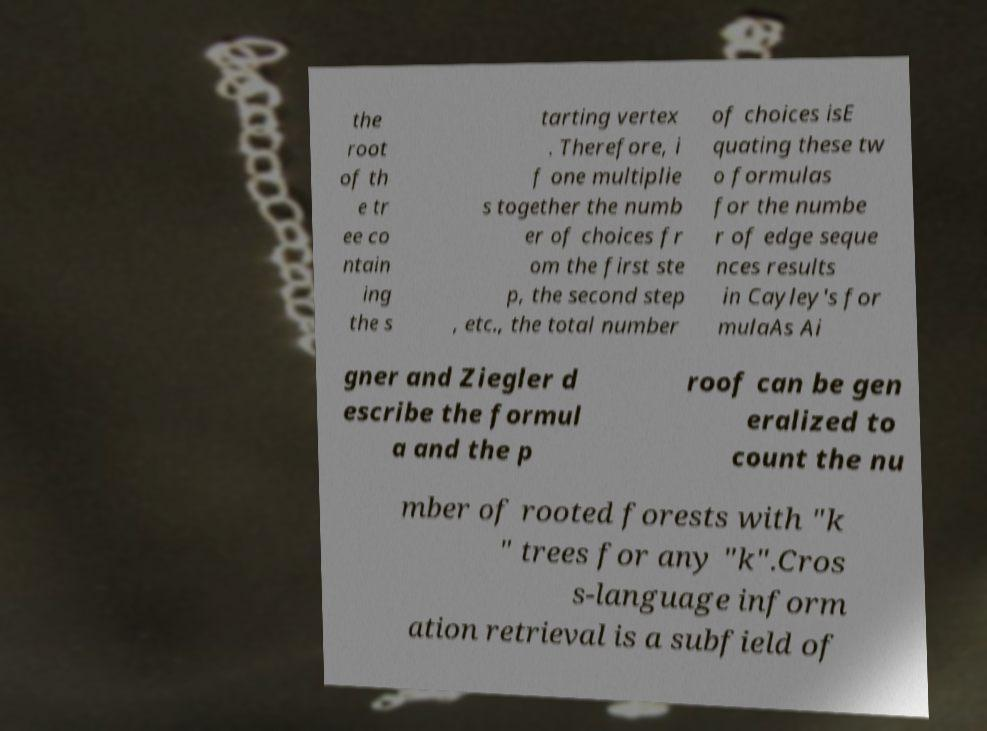I need the written content from this picture converted into text. Can you do that? the root of th e tr ee co ntain ing the s tarting vertex . Therefore, i f one multiplie s together the numb er of choices fr om the first ste p, the second step , etc., the total number of choices isE quating these tw o formulas for the numbe r of edge seque nces results in Cayley's for mulaAs Ai gner and Ziegler d escribe the formul a and the p roof can be gen eralized to count the nu mber of rooted forests with "k " trees for any "k".Cros s-language inform ation retrieval is a subfield of 